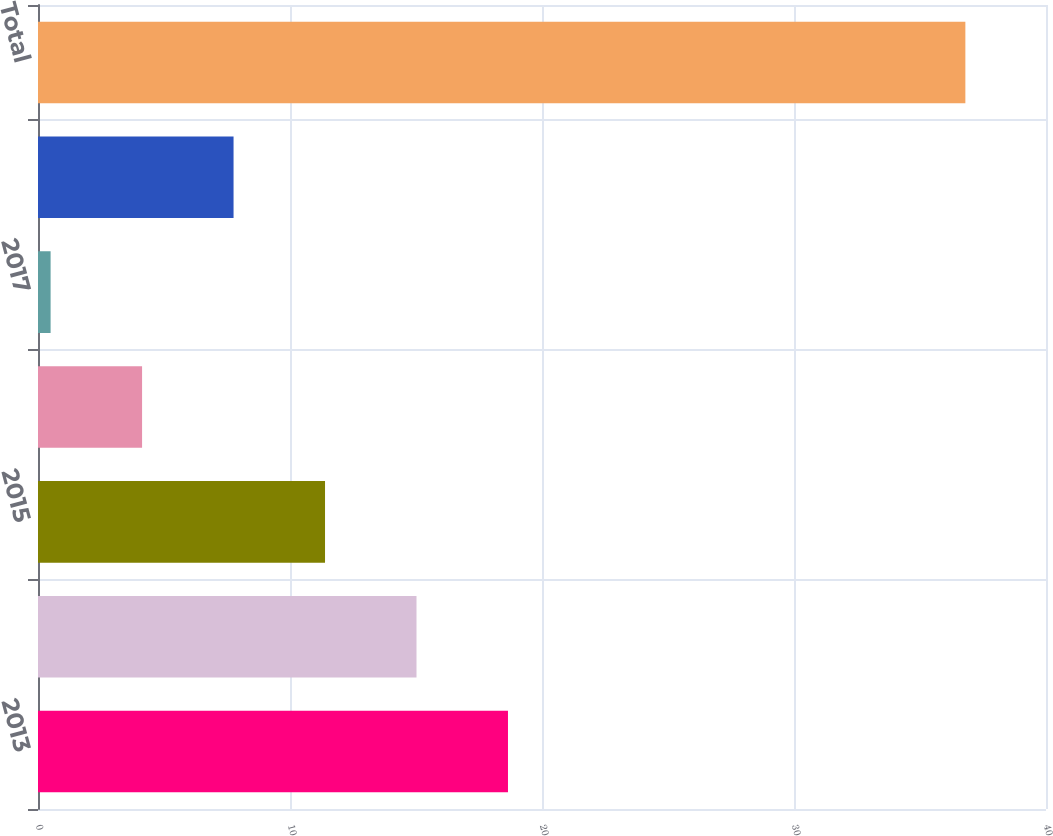Convert chart to OTSL. <chart><loc_0><loc_0><loc_500><loc_500><bar_chart><fcel>2013<fcel>2014<fcel>2015<fcel>2016<fcel>2017<fcel>Thereafter<fcel>Total<nl><fcel>18.65<fcel>15.02<fcel>11.39<fcel>4.13<fcel>0.5<fcel>7.76<fcel>36.8<nl></chart> 